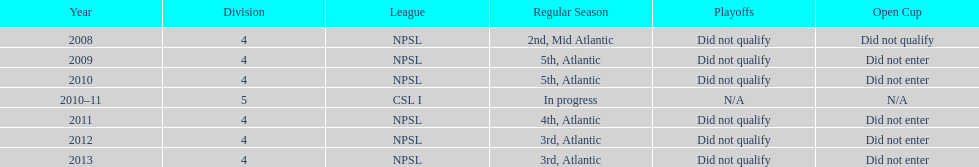Excluding npsl, what is another league that the ny men's soccer team has been a part of? CSL I. 